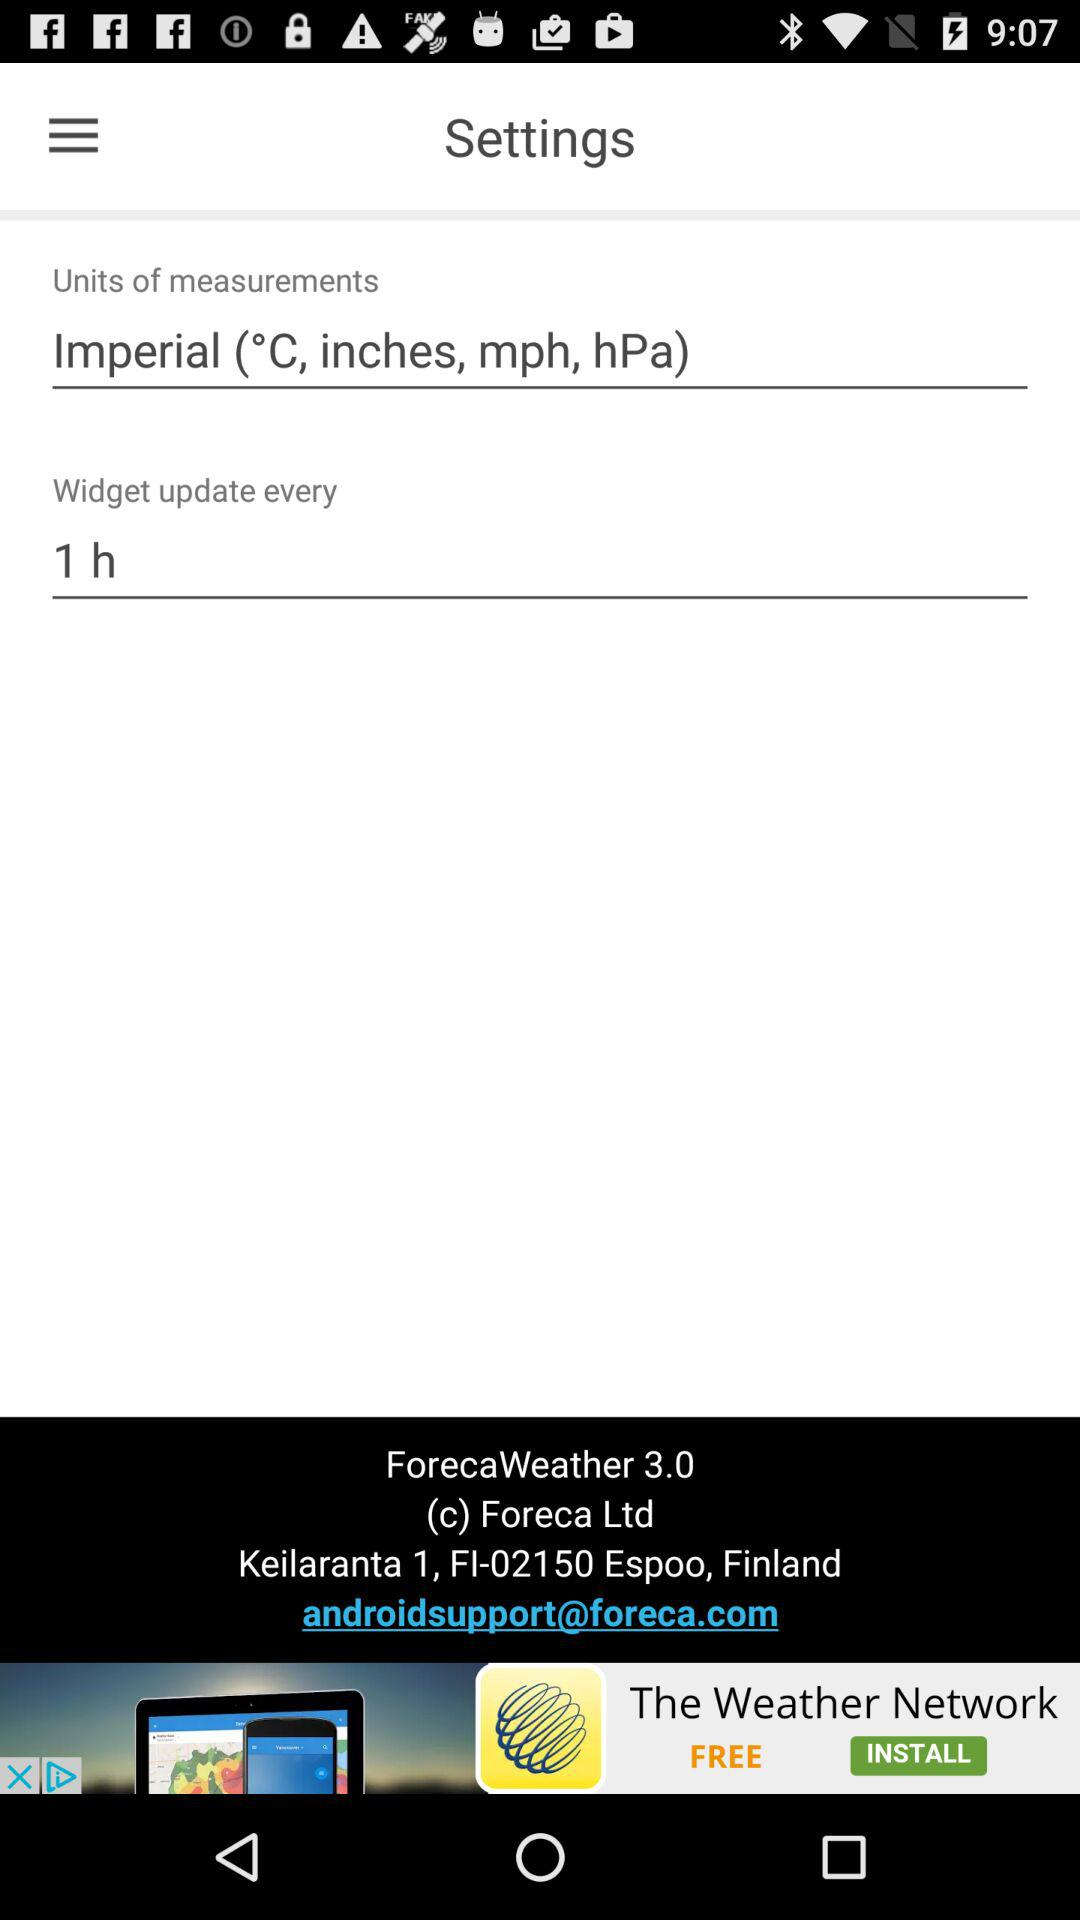What units of measurement are mentioned? The mentioned units of measurement are °C, inches, mph and hPa. 